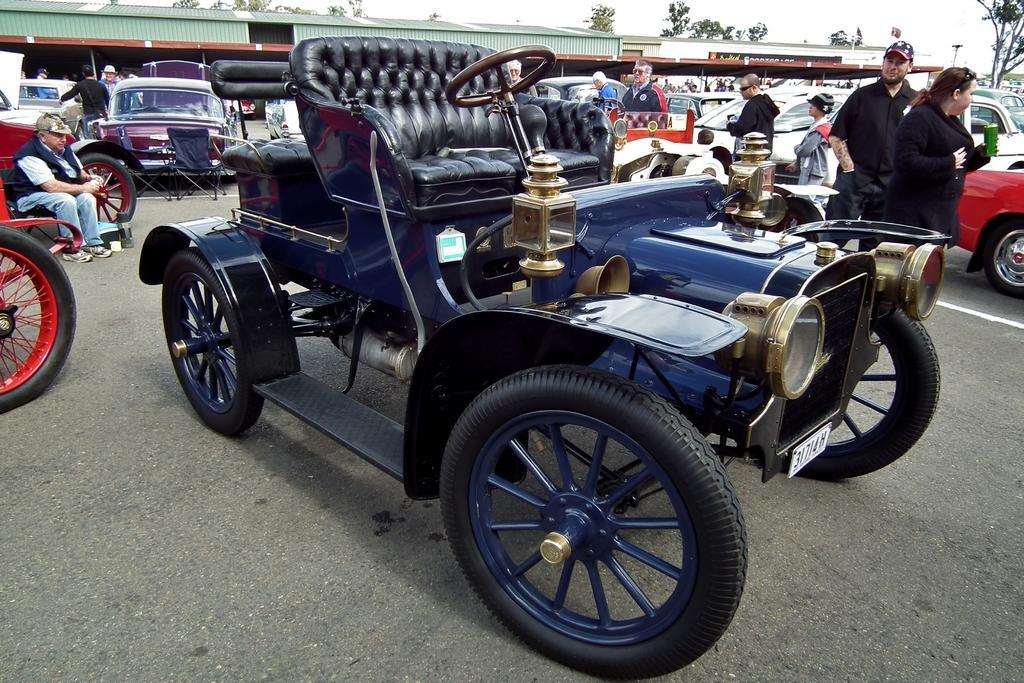Describe this image in one or two sentences. In this image there is a road, there are vehicles, there are persons, there is a person sitting towards the left of the image, there is a shed, there are trees, there is the sky. 